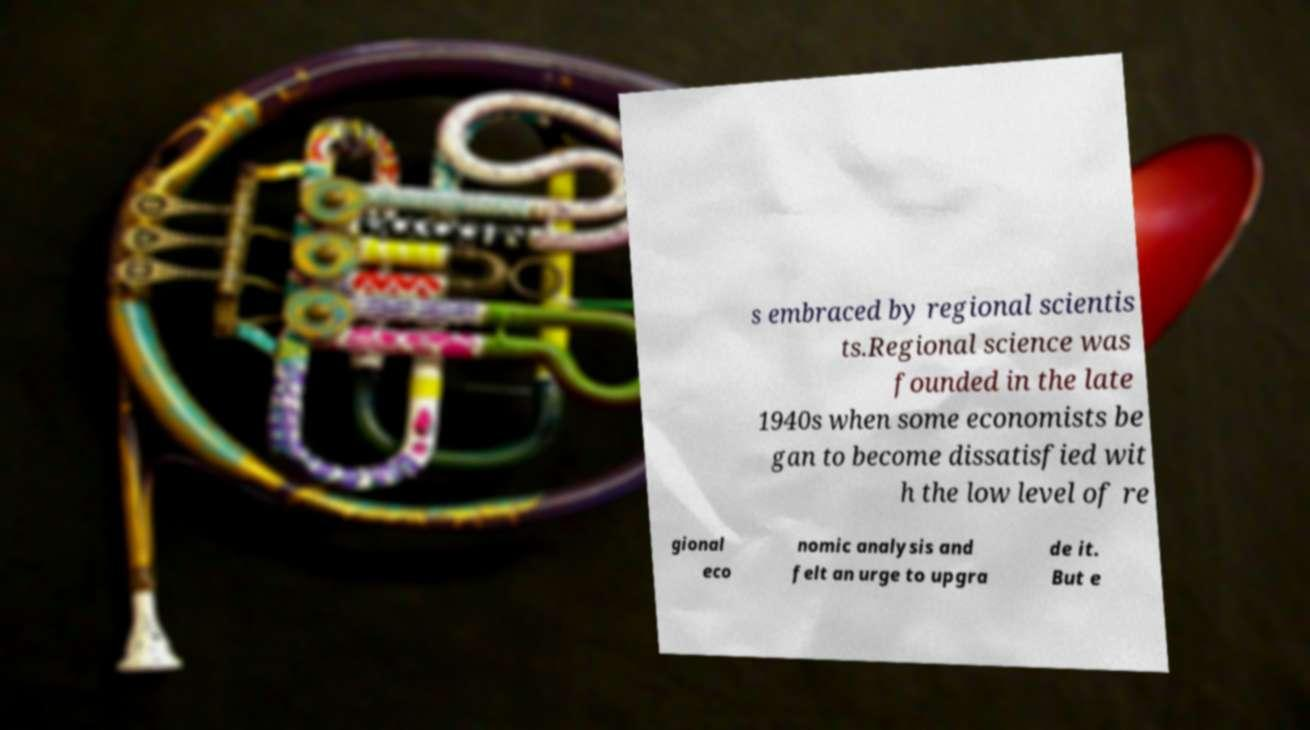What messages or text are displayed in this image? I need them in a readable, typed format. s embraced by regional scientis ts.Regional science was founded in the late 1940s when some economists be gan to become dissatisfied wit h the low level of re gional eco nomic analysis and felt an urge to upgra de it. But e 